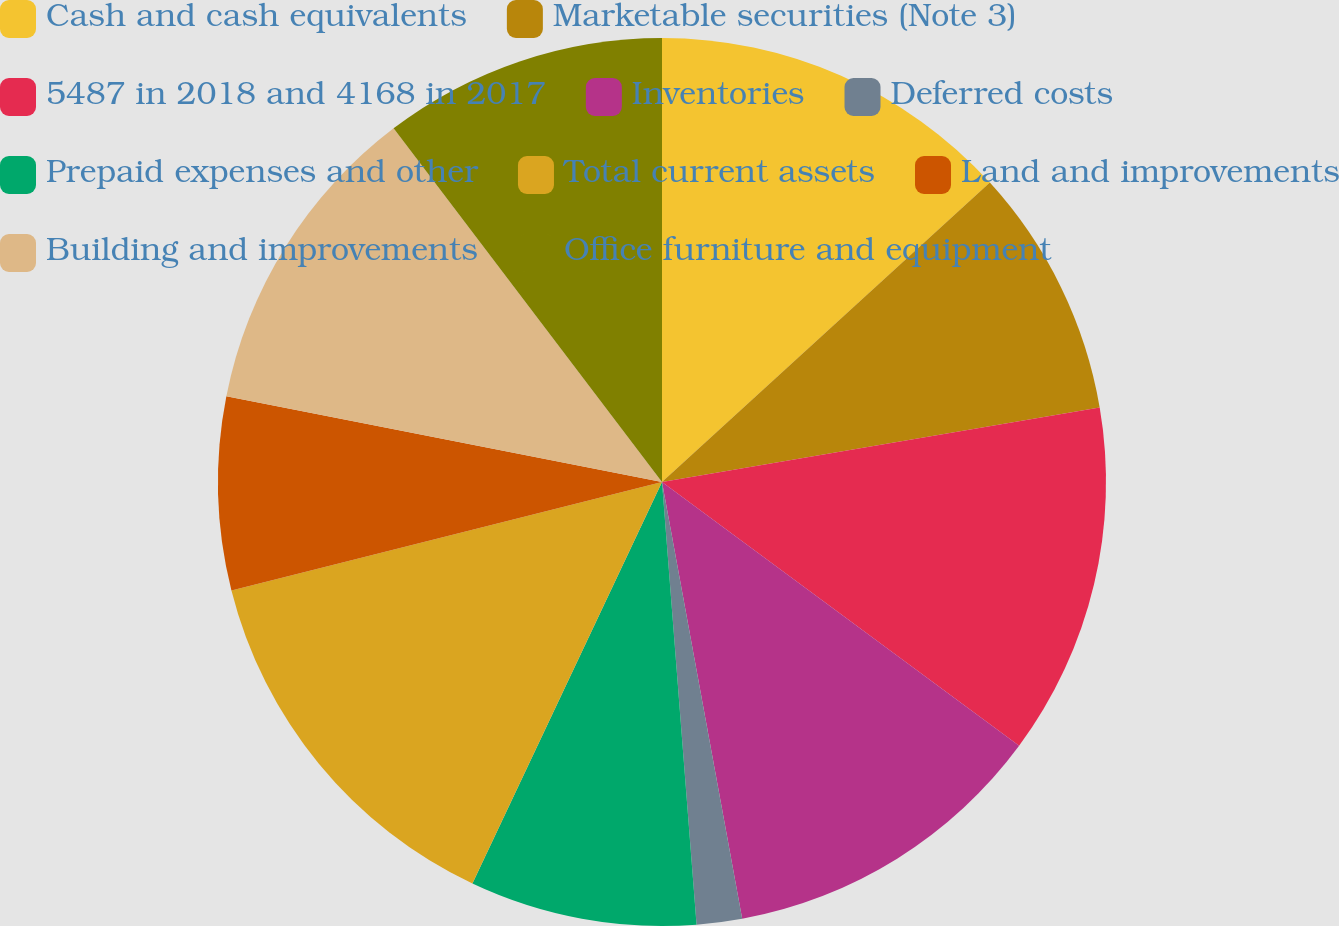Convert chart. <chart><loc_0><loc_0><loc_500><loc_500><pie_chart><fcel>Cash and cash equivalents<fcel>Marketable securities (Note 3)<fcel>5487 in 2018 and 4168 in 2017<fcel>Inventories<fcel>Deferred costs<fcel>Prepaid expenses and other<fcel>Total current assets<fcel>Land and improvements<fcel>Building and improvements<fcel>Office furniture and equipment<nl><fcel>13.22%<fcel>9.09%<fcel>12.81%<fcel>11.98%<fcel>1.65%<fcel>8.26%<fcel>14.05%<fcel>7.02%<fcel>11.57%<fcel>10.33%<nl></chart> 